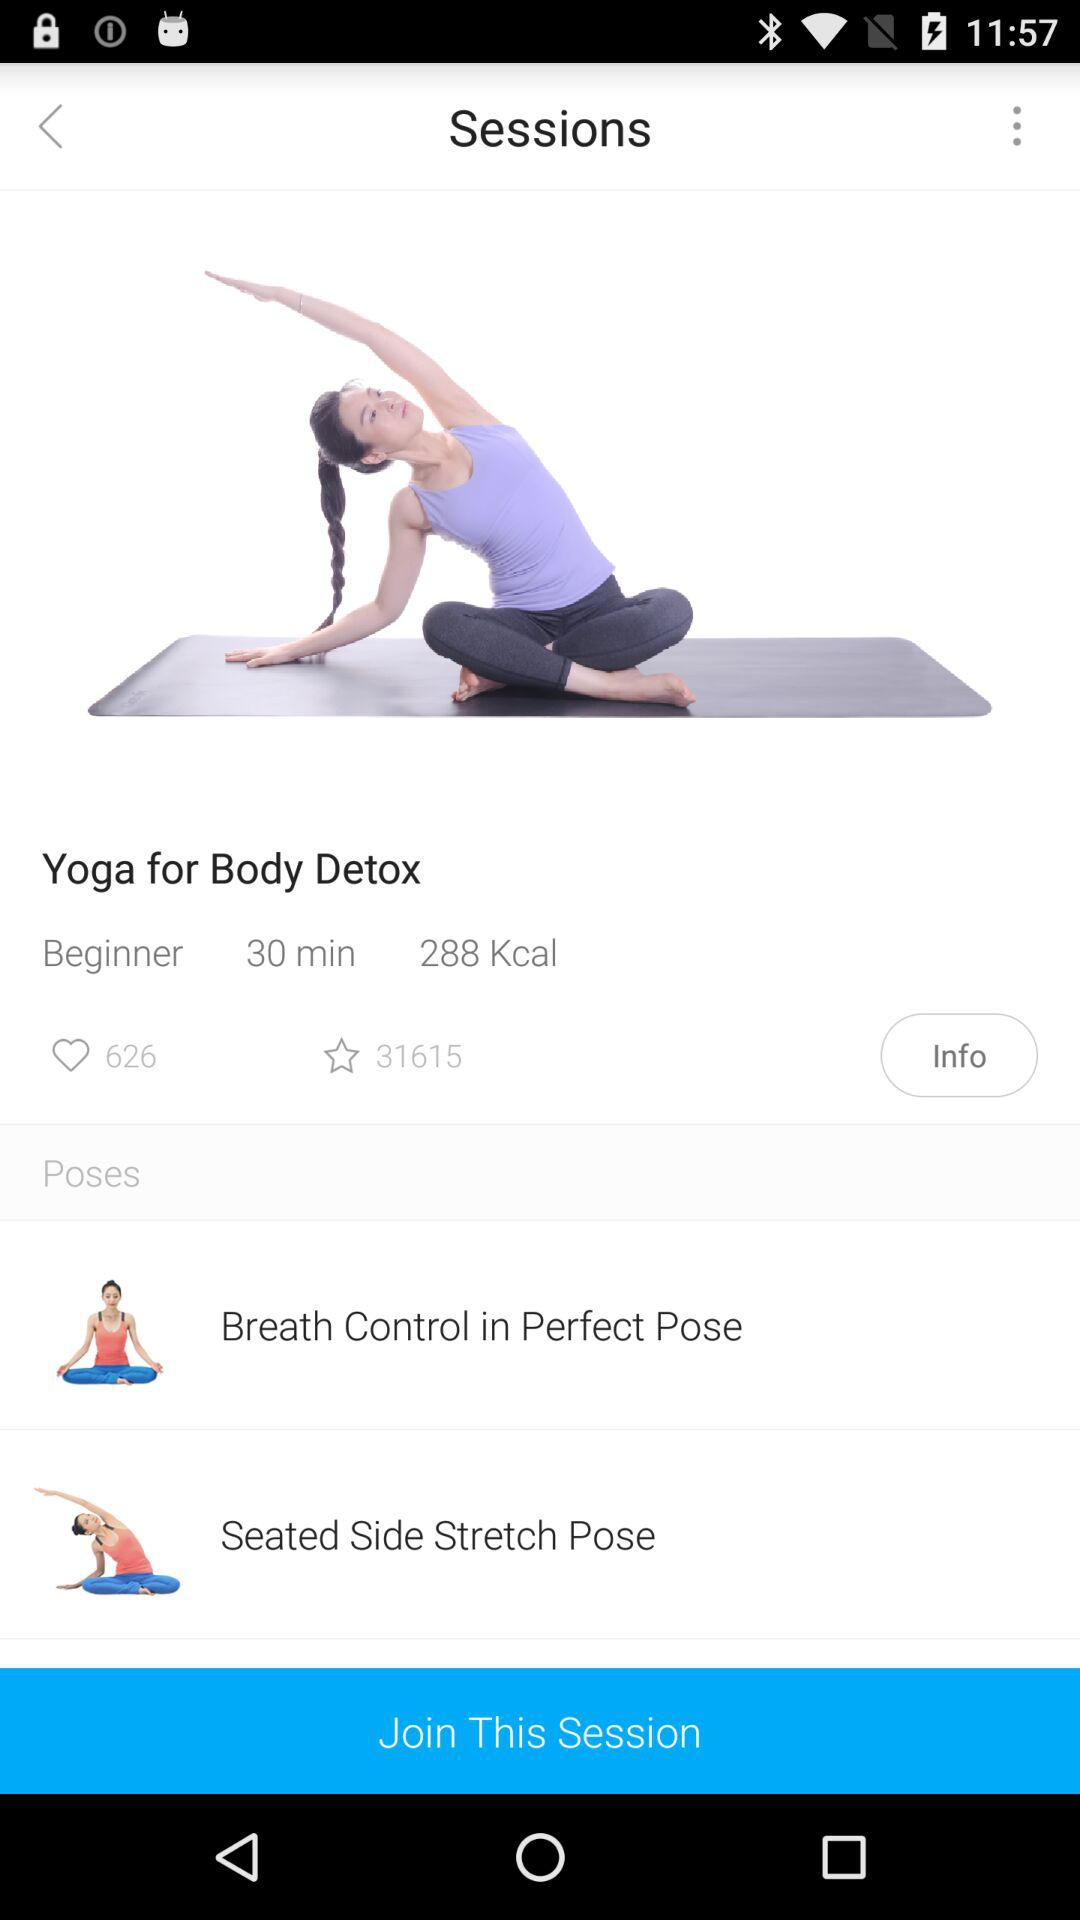How many calories are burned in this session?
Answer the question using a single word or phrase. 288 Kcal 